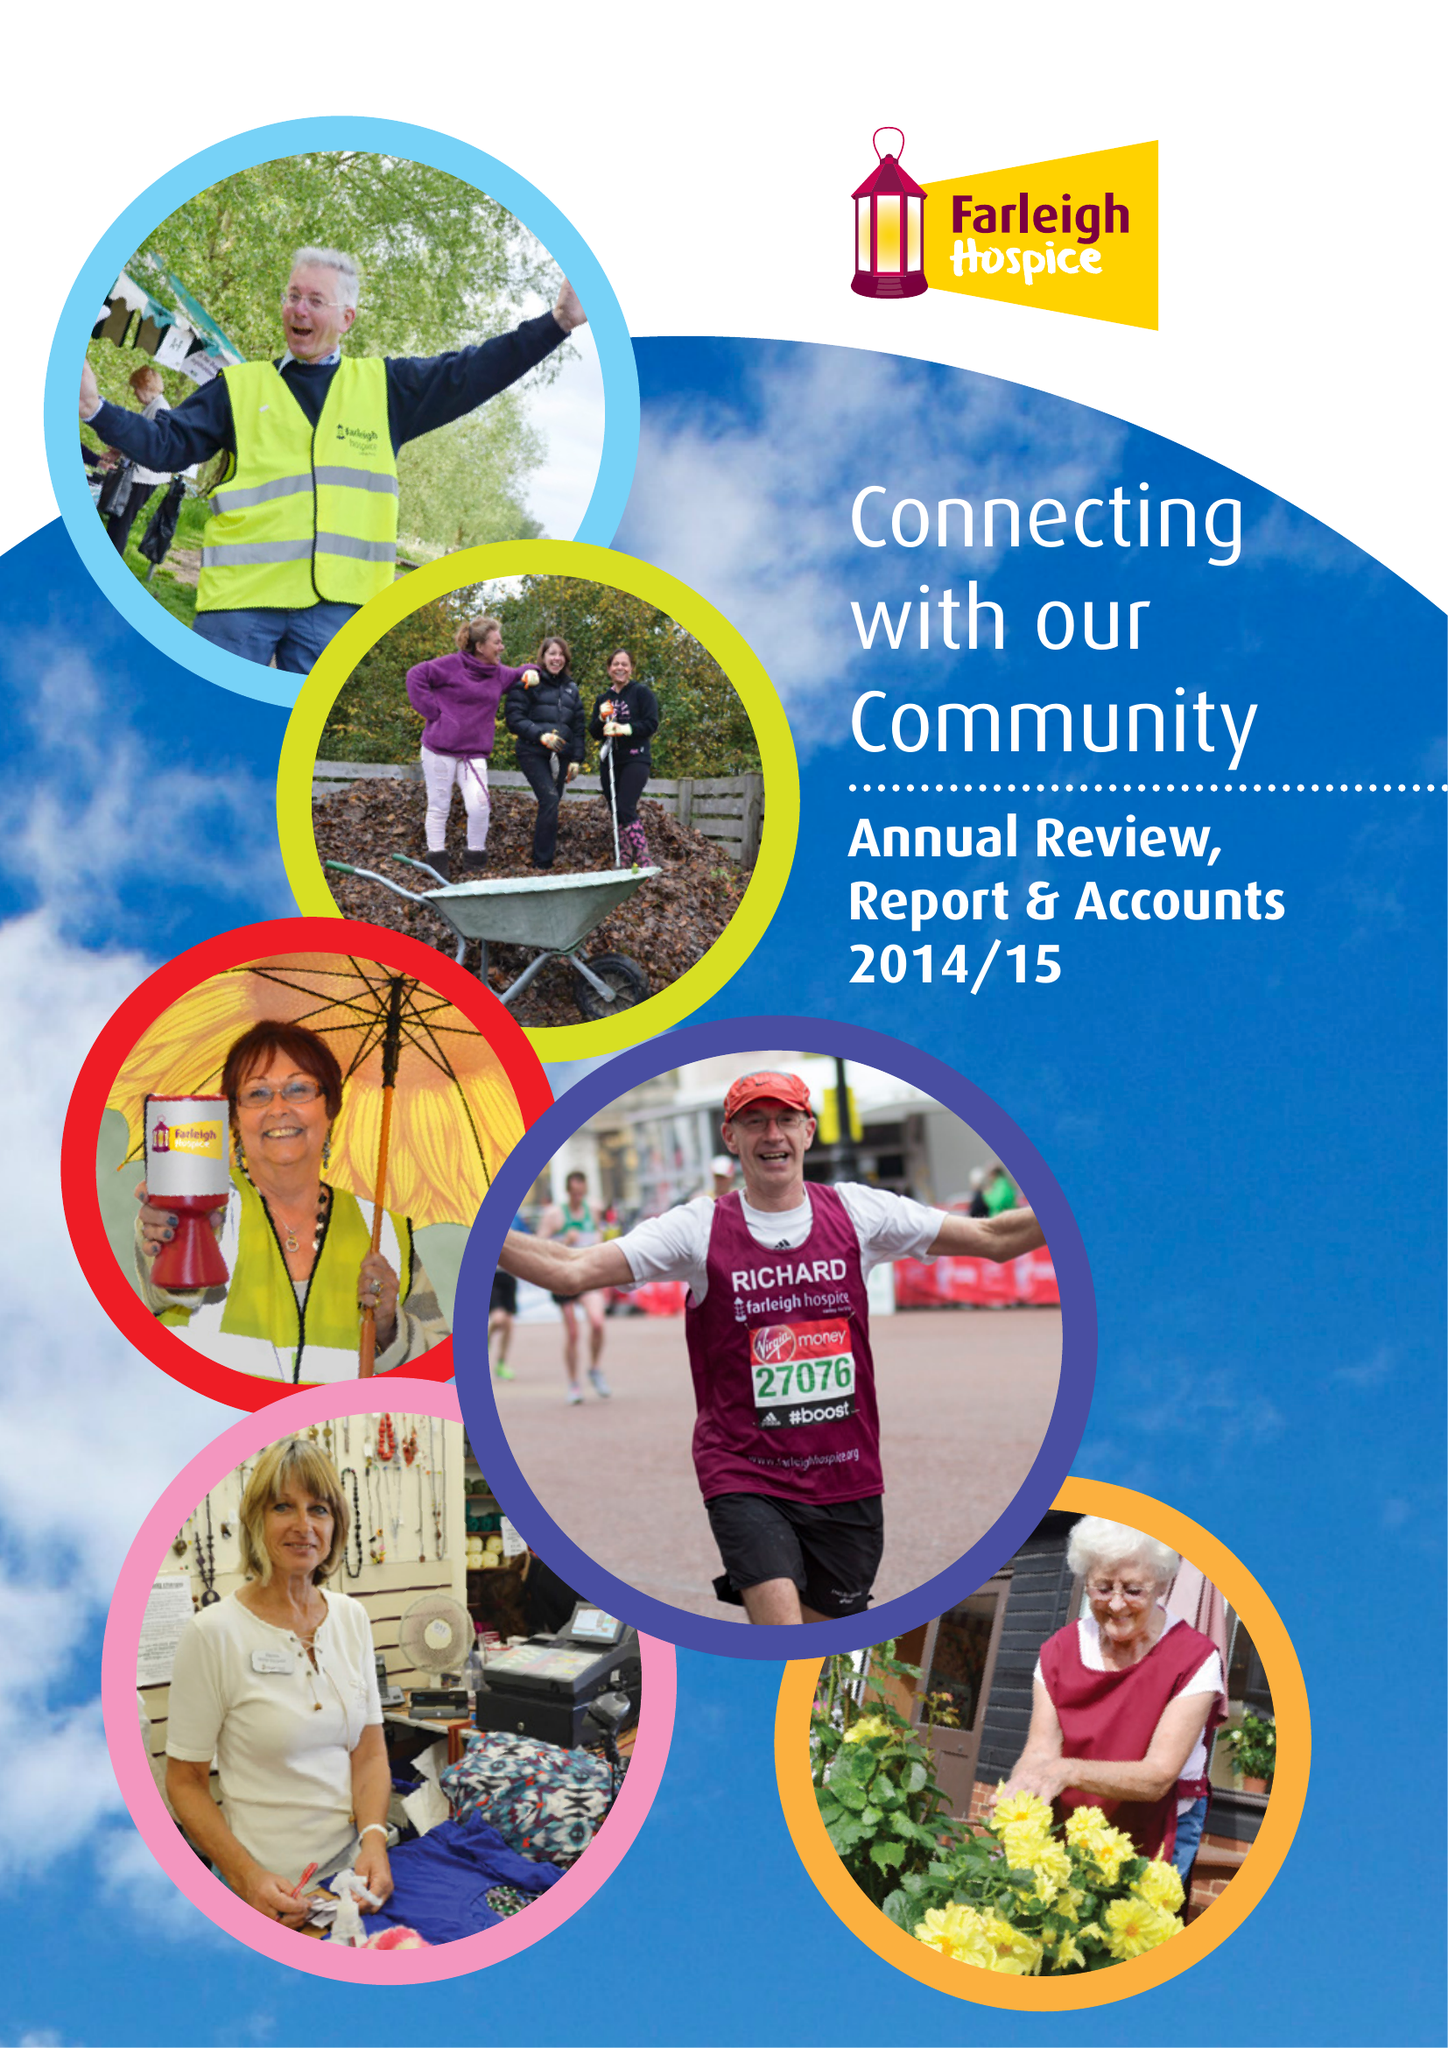What is the value for the report_date?
Answer the question using a single word or phrase. 2015-03-31 